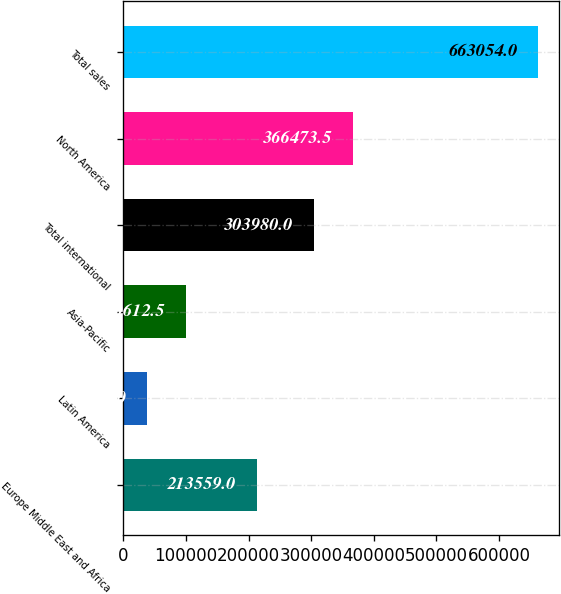Convert chart. <chart><loc_0><loc_0><loc_500><loc_500><bar_chart><fcel>Europe Middle East and Africa<fcel>Latin America<fcel>Asia-Pacific<fcel>Total international<fcel>North America<fcel>Total sales<nl><fcel>213559<fcel>38119<fcel>100612<fcel>303980<fcel>366474<fcel>663054<nl></chart> 